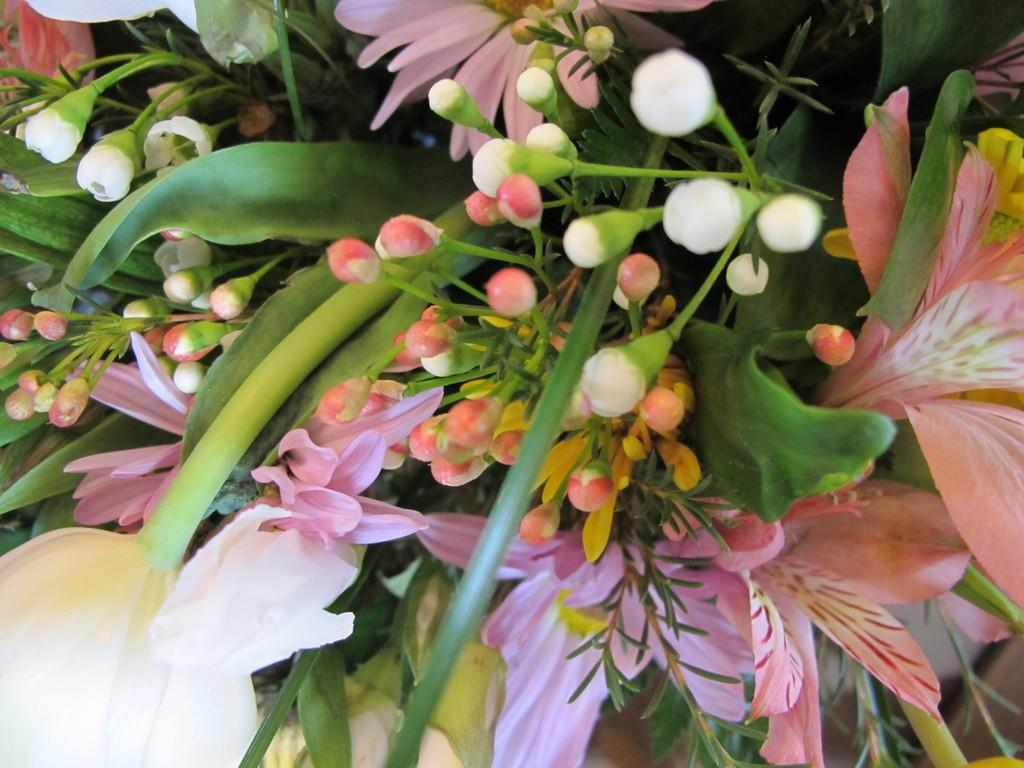What type of plants can be seen in the image? There are flowers in the image. Can you describe the stage of growth for some of the plants? Yes, there are buds in the image, which are flowers in the early stages of development. What is the price of the cherry in the image? There is no cherry present in the image, so it is not possible to determine its price. 